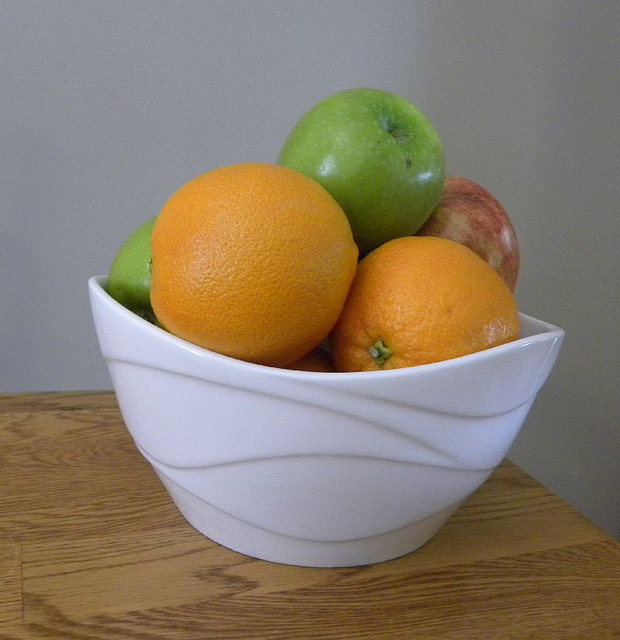<image>Would you call the bowl of fruit a miniature? I don't know if you would call the bowl of fruit a miniature. It depends on the size. Would you call the bowl of fruit a miniature? I am not sure if I would call the bowl of fruit a miniature. It is more likely not a miniature. 